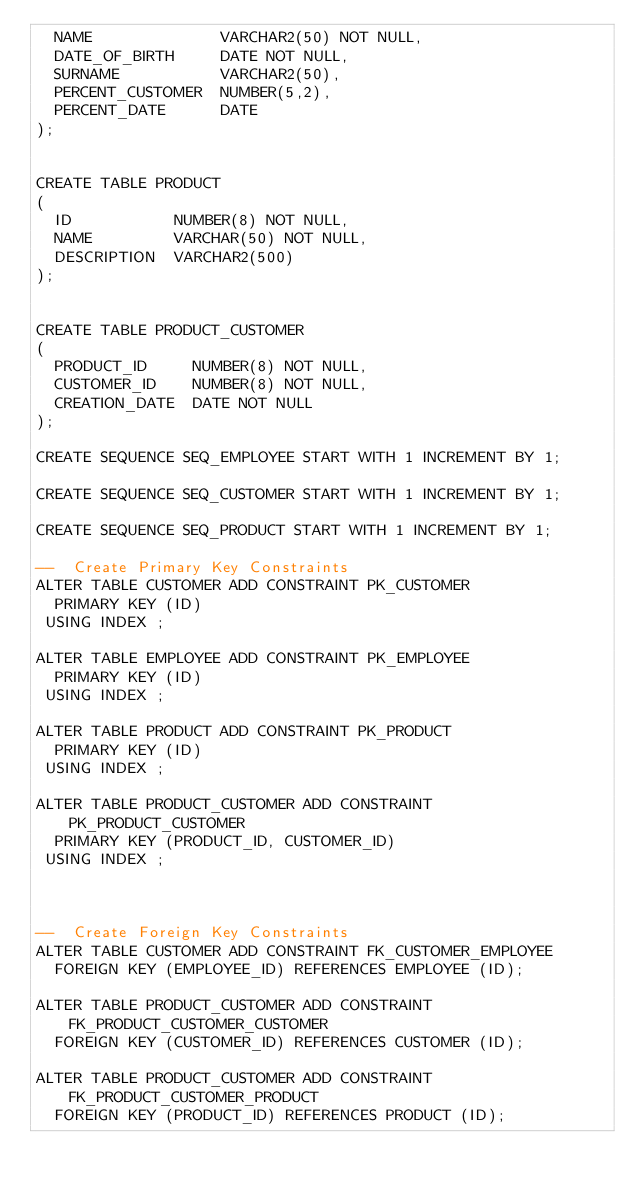Convert code to text. <code><loc_0><loc_0><loc_500><loc_500><_SQL_>	NAME              VARCHAR2(50) NOT NULL,
	DATE_OF_BIRTH     DATE NOT NULL,
	SURNAME           VARCHAR2(50),
	PERCENT_CUSTOMER  NUMBER(5,2),
	PERCENT_DATE      DATE
);


CREATE TABLE PRODUCT
(
	ID           NUMBER(8) NOT NULL,
	NAME         VARCHAR(50) NOT NULL,
	DESCRIPTION  VARCHAR2(500)
);


CREATE TABLE PRODUCT_CUSTOMER
(
	PRODUCT_ID     NUMBER(8) NOT NULL,
	CUSTOMER_ID    NUMBER(8) NOT NULL,
	CREATION_DATE  DATE NOT NULL
);

CREATE SEQUENCE SEQ_EMPLOYEE START WITH 1 INCREMENT BY 1;

CREATE SEQUENCE SEQ_CUSTOMER START WITH 1 INCREMENT BY 1;

CREATE SEQUENCE SEQ_PRODUCT START WITH 1 INCREMENT BY 1;

--  Create Primary Key Constraints 
ALTER TABLE CUSTOMER ADD CONSTRAINT PK_CUSTOMER 
	PRIMARY KEY (ID) 
 USING INDEX ;

ALTER TABLE EMPLOYEE ADD CONSTRAINT PK_EMPLOYEE 
	PRIMARY KEY (ID) 
 USING INDEX ;

ALTER TABLE PRODUCT ADD CONSTRAINT PK_PRODUCT 
	PRIMARY KEY (ID) 
 USING INDEX ;

ALTER TABLE PRODUCT_CUSTOMER ADD CONSTRAINT PK_PRODUCT_CUSTOMER 
	PRIMARY KEY (PRODUCT_ID, CUSTOMER_ID) 
 USING INDEX ;



--  Create Foreign Key Constraints 
ALTER TABLE CUSTOMER ADD CONSTRAINT FK_CUSTOMER_EMPLOYEE 
	FOREIGN KEY (EMPLOYEE_ID) REFERENCES EMPLOYEE (ID);

ALTER TABLE PRODUCT_CUSTOMER ADD CONSTRAINT FK_PRODUCT_CUSTOMER_CUSTOMER 
	FOREIGN KEY (CUSTOMER_ID) REFERENCES CUSTOMER (ID);

ALTER TABLE PRODUCT_CUSTOMER ADD CONSTRAINT FK_PRODUCT_CUSTOMER_PRODUCT 
	FOREIGN KEY (PRODUCT_ID) REFERENCES PRODUCT (ID);
	

</code> 